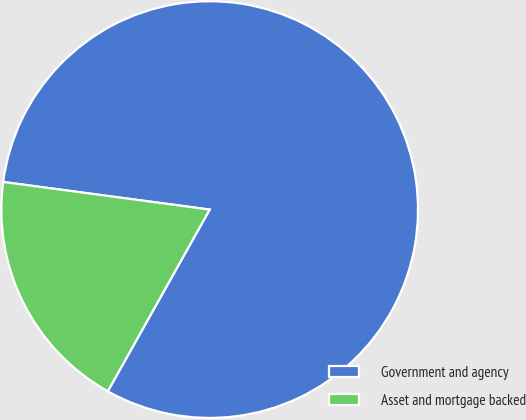<chart> <loc_0><loc_0><loc_500><loc_500><pie_chart><fcel>Government and agency<fcel>Asset and mortgage backed<nl><fcel>81.02%<fcel>18.98%<nl></chart> 